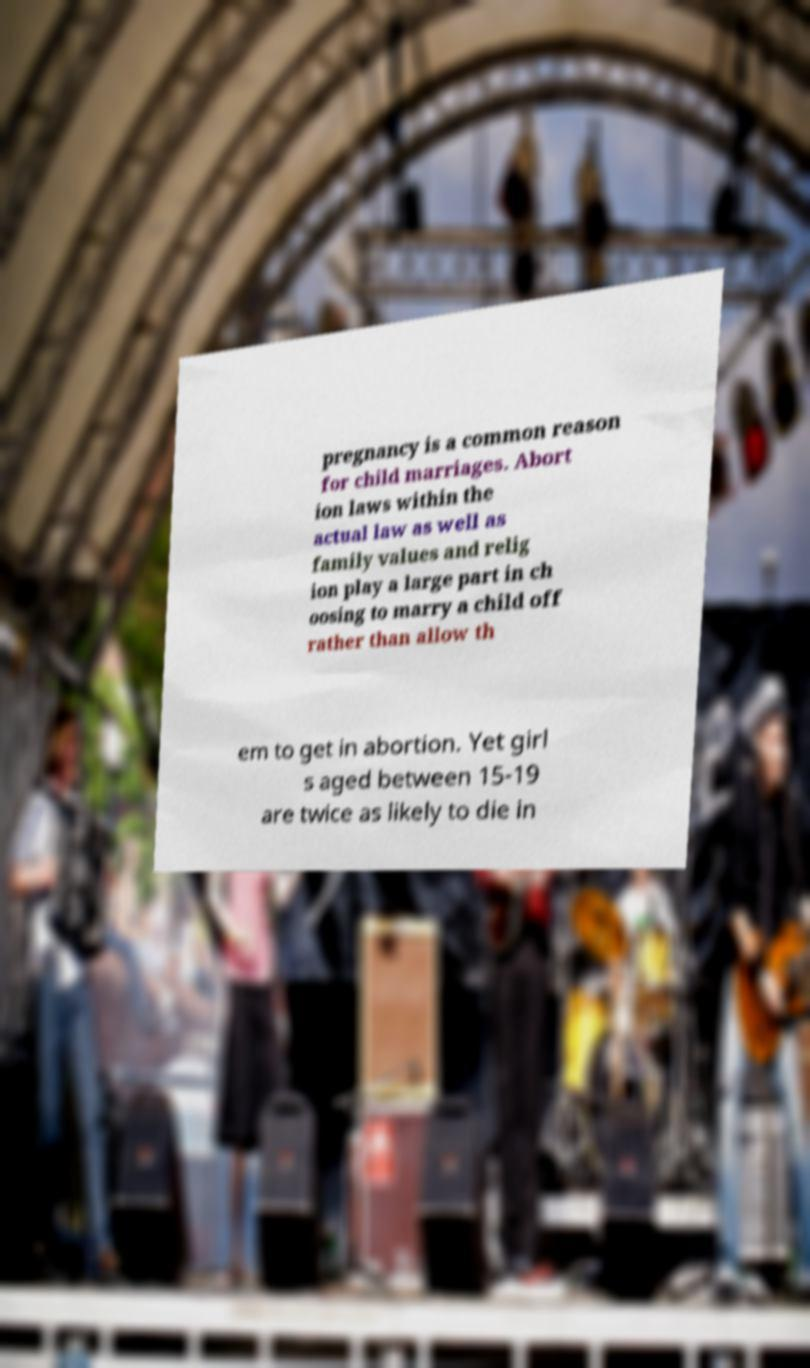Can you read and provide the text displayed in the image?This photo seems to have some interesting text. Can you extract and type it out for me? pregnancy is a common reason for child marriages. Abort ion laws within the actual law as well as family values and relig ion play a large part in ch oosing to marry a child off rather than allow th em to get in abortion. Yet girl s aged between 15-19 are twice as likely to die in 